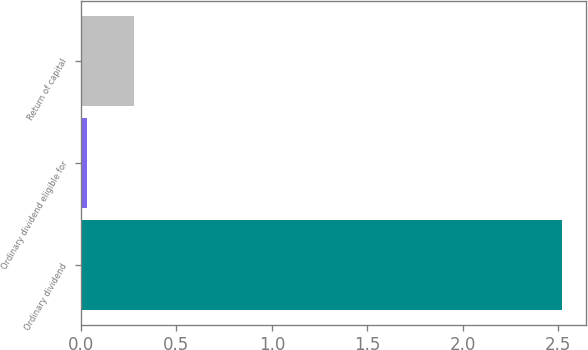Convert chart. <chart><loc_0><loc_0><loc_500><loc_500><bar_chart><fcel>Ordinary dividend<fcel>Ordinary dividend eligible for<fcel>Return of capital<nl><fcel>2.52<fcel>0.03<fcel>0.28<nl></chart> 